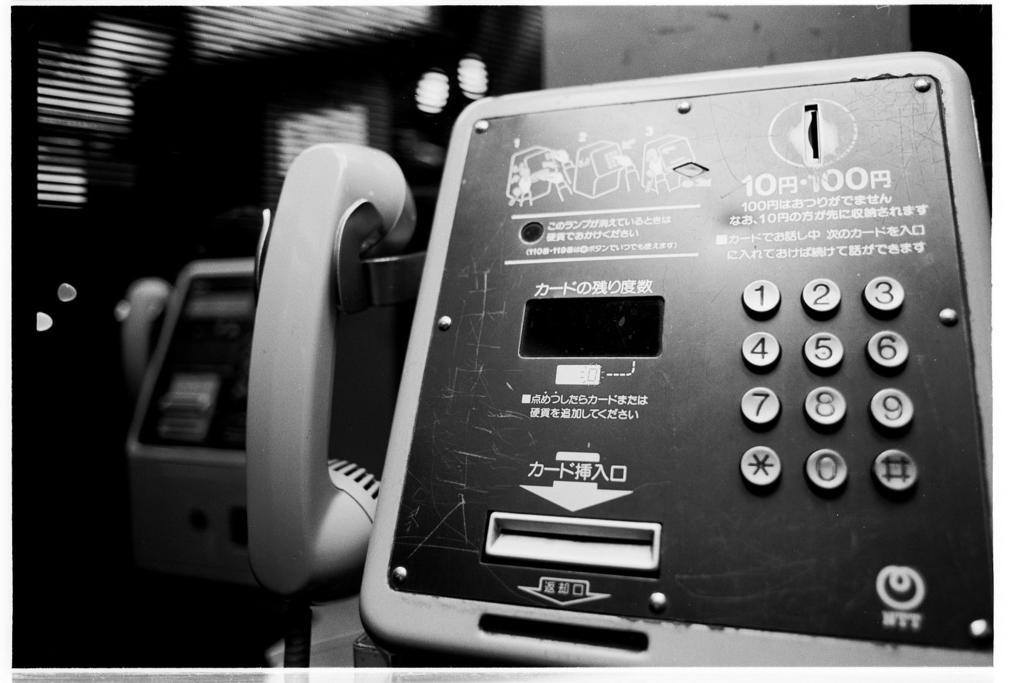What objects are present in the image? There are telephones in the image. What can be seen in the background of the image? There is a wall in the background of the image. How would you describe the background of the image? The background is blurred. What type of ornament is hanging from the telephones in the image? There is no ornament hanging from the telephones in the image. Can you describe the loaf of bread on the table in the image? There is no loaf of bread present in the image. 